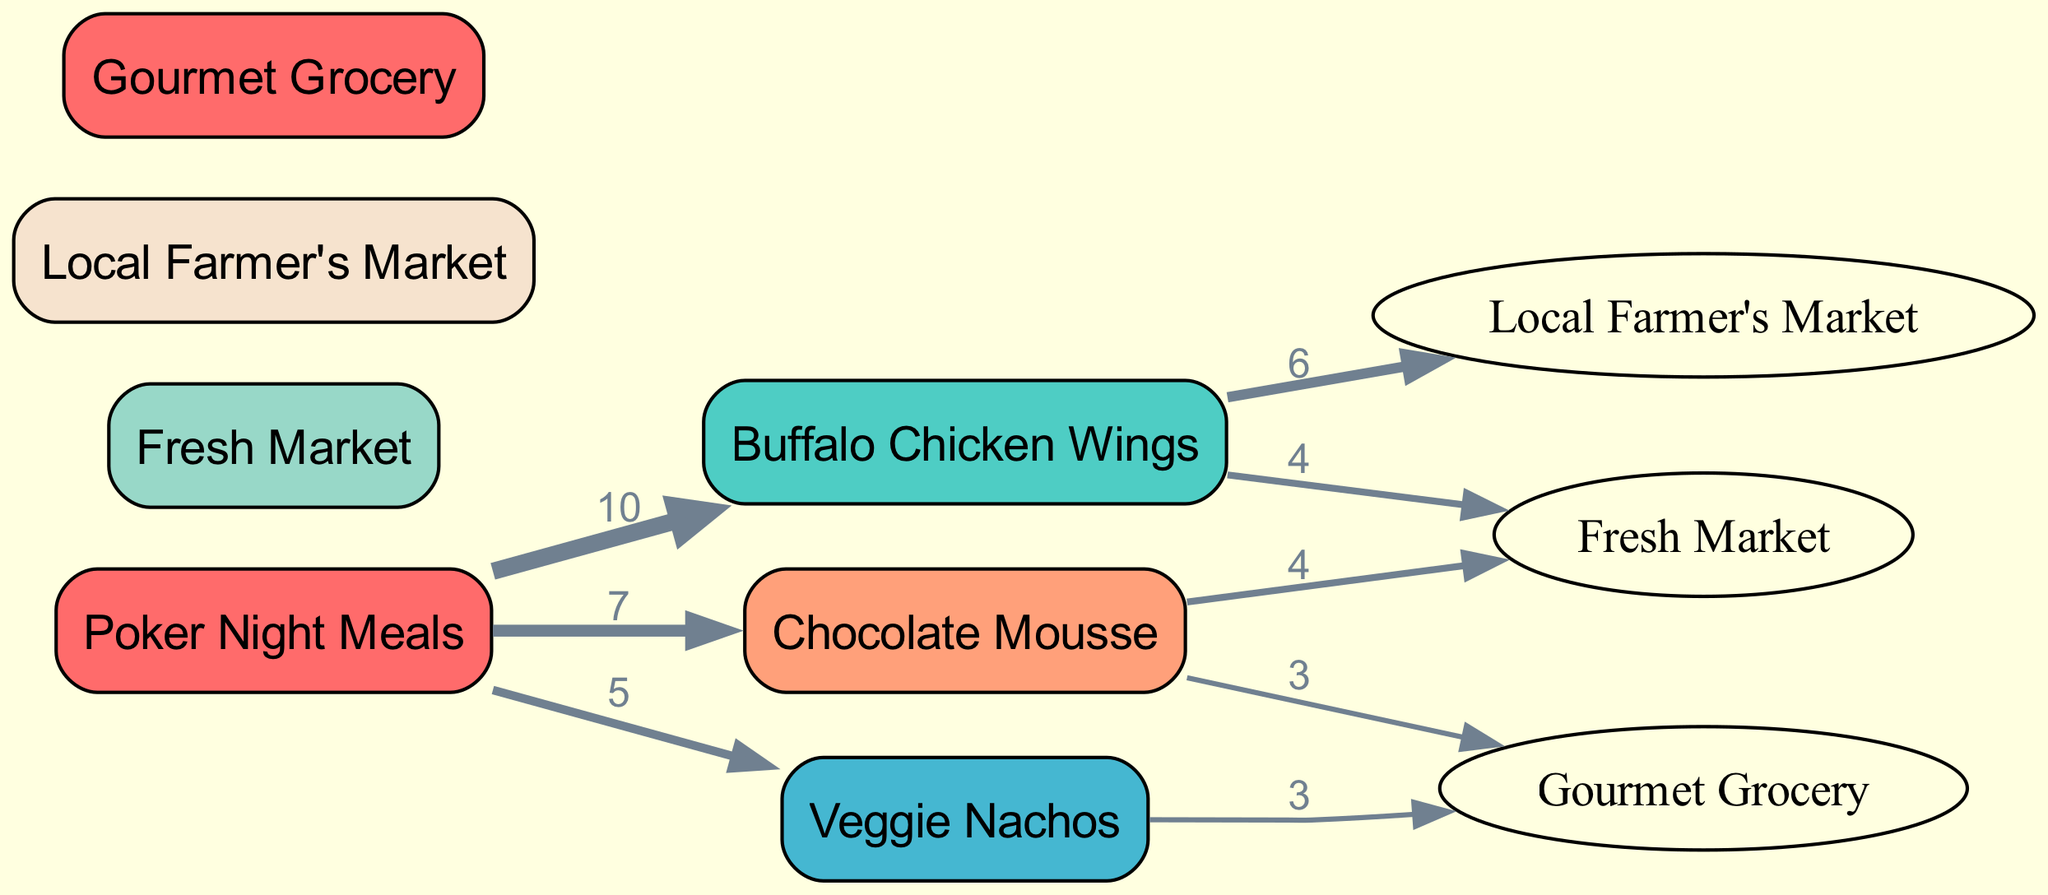What meal has the highest sourcing frequency? The diagram shows that "Buffalo Chicken Wings" has a sourcing frequency of 10, which is higher than any other meal. Therefore, the answer can be derived by comparing the values associated with each meal node.
Answer: Buffalo Chicken Wings How many suppliers are involved in sourcing ingredients? The diagram lists three suppliers: "Fresh Market," "Local Farmer's Market," and "Gourmet Grocery." Therefore, counting the supplier nodes provides the answer.
Answer: 3 What is the sourcing frequency for Veggie Nachos? The edge connecting "Poker Night Meals" to "Veggie Nachos" specifies a value of 5, indicating that Veggie Nachos were sourced with a frequency of 5. Hence, looking directly at the edge from the meals node to the Veggie Nachos node gives the answer.
Answer: 5 Which supplier provides ingredients for the Chocolate Mousse? The edges show that "Chocolate Mousse" sources from "Fresh Market" and "Gourmet Grocery." Therefore, identifying the direct connections from the Chocolate Mousse node leads to the two suppliers.
Answer: Fresh Market, Gourmet Grocery What is the total frequency of sourcing ingredients for all meals? To find the total frequency, sum the values of all edges outgoing from the "Poker Night Meals" node: 10 (Buffalo Chicken Wings) + 5 (Veggie Nachos) + 7 (Chocolate Mousse) = 22. The reasoning involves adding all meal frequencies.
Answer: 22 Which supplier has the most connections to meals? Analyzing the sources, "Fresh Market" connects to two meals (Buffalo Chicken Wings and Chocolate Mousse), while "Local Farmer's Market" connects to one, and "Gourmet Grocery" connects to two as well. Therefore, the highest connection count indicates that "Fresh Market" and "Gourmet Grocery" are tied in this regard.
Answer: Fresh Market, Gourmet Grocery How many total meal types are represented in the diagram? The nodes for meals show three types: "Buffalo Chicken Wings," "Veggie Nachos," and "Chocolate Mousse." Thus, simply counting these meal nodes yields the answer.
Answer: 3 What is the cost value assigned to sourcing from the Local Farmer's Market for Buffalo Chicken Wings? The edge from "Buffalo Chicken Wings" to "Local Farmer's Market" specifies a value of 6, which indicates the cost of sourcing from this supplier specifically for the Buffalo Chicken Wings meal. Thus, identifying the edge directly gives this sourcing cost.
Answer: 6 Which meal has the least sourcing frequency? Comparing the sourcing frequencies of all meals shows that "Veggie Nachos" has a frequency of 5, which is lower than both "Buffalo Chicken Wings" (10) and "Chocolate Mousse" (7). Therefore, identifying the meal with the lowest value resolves the query.
Answer: Veggie Nachos 